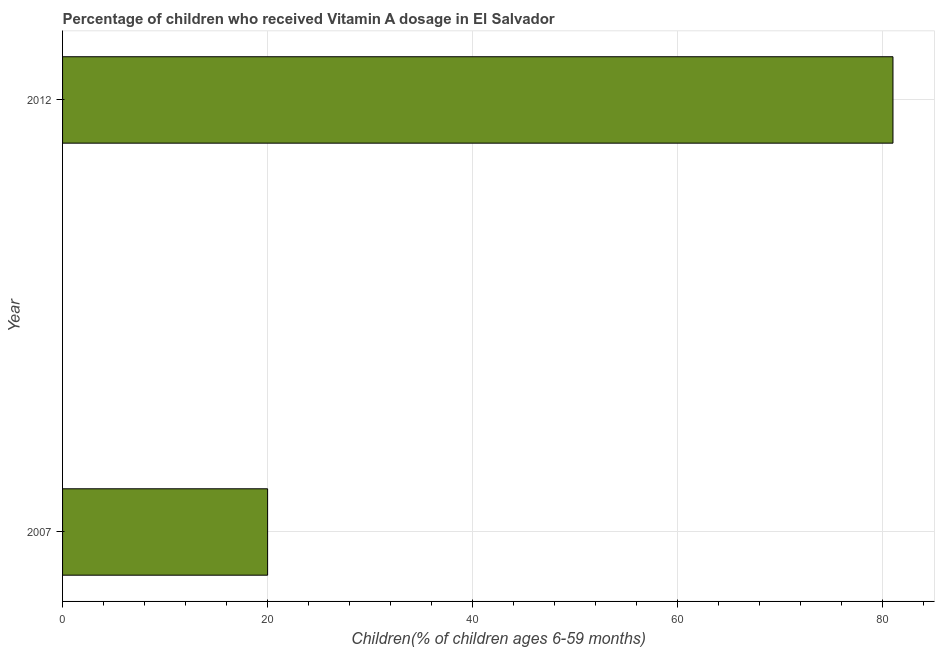Does the graph contain any zero values?
Ensure brevity in your answer.  No. Does the graph contain grids?
Your response must be concise. Yes. What is the title of the graph?
Make the answer very short. Percentage of children who received Vitamin A dosage in El Salvador. What is the label or title of the X-axis?
Your answer should be compact. Children(% of children ages 6-59 months). What is the label or title of the Y-axis?
Your answer should be compact. Year. What is the vitamin a supplementation coverage rate in 2007?
Offer a very short reply. 20. In which year was the vitamin a supplementation coverage rate maximum?
Offer a terse response. 2012. What is the sum of the vitamin a supplementation coverage rate?
Ensure brevity in your answer.  101. What is the difference between the vitamin a supplementation coverage rate in 2007 and 2012?
Give a very brief answer. -61. What is the average vitamin a supplementation coverage rate per year?
Your answer should be compact. 50. What is the median vitamin a supplementation coverage rate?
Give a very brief answer. 50.5. In how many years, is the vitamin a supplementation coverage rate greater than 28 %?
Keep it short and to the point. 1. What is the ratio of the vitamin a supplementation coverage rate in 2007 to that in 2012?
Keep it short and to the point. 0.25. Is the vitamin a supplementation coverage rate in 2007 less than that in 2012?
Provide a succinct answer. Yes. In how many years, is the vitamin a supplementation coverage rate greater than the average vitamin a supplementation coverage rate taken over all years?
Your answer should be very brief. 1. Are all the bars in the graph horizontal?
Provide a short and direct response. Yes. How many years are there in the graph?
Your answer should be compact. 2. What is the Children(% of children ages 6-59 months) of 2007?
Offer a very short reply. 20. What is the Children(% of children ages 6-59 months) of 2012?
Offer a very short reply. 81. What is the difference between the Children(% of children ages 6-59 months) in 2007 and 2012?
Provide a succinct answer. -61. What is the ratio of the Children(% of children ages 6-59 months) in 2007 to that in 2012?
Give a very brief answer. 0.25. 